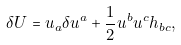<formula> <loc_0><loc_0><loc_500><loc_500>\delta U = u _ { a } \delta u ^ { a } + \frac { 1 } { 2 } u ^ { b } u ^ { c } h _ { b c } ,</formula> 